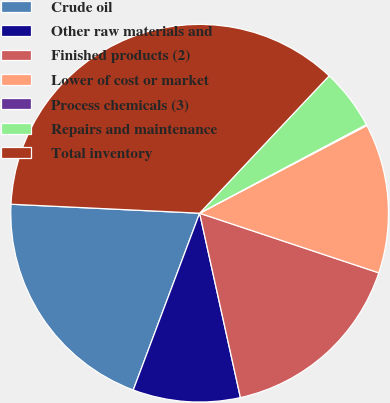Convert chart to OTSL. <chart><loc_0><loc_0><loc_500><loc_500><pie_chart><fcel>Crude oil<fcel>Other raw materials and<fcel>Finished products (2)<fcel>Lower of cost or market<fcel>Process chemicals (3)<fcel>Repairs and maintenance<fcel>Total inventory<nl><fcel>20.04%<fcel>9.18%<fcel>16.42%<fcel>12.8%<fcel>0.09%<fcel>5.19%<fcel>36.27%<nl></chart> 